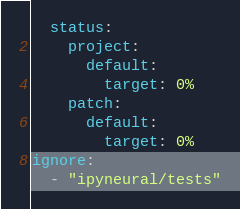<code> <loc_0><loc_0><loc_500><loc_500><_YAML_>  status:
    project:
      default:
        target: 0%
    patch:
      default:
        target: 0%
ignore:
  - "ipyneural/tests"
</code> 